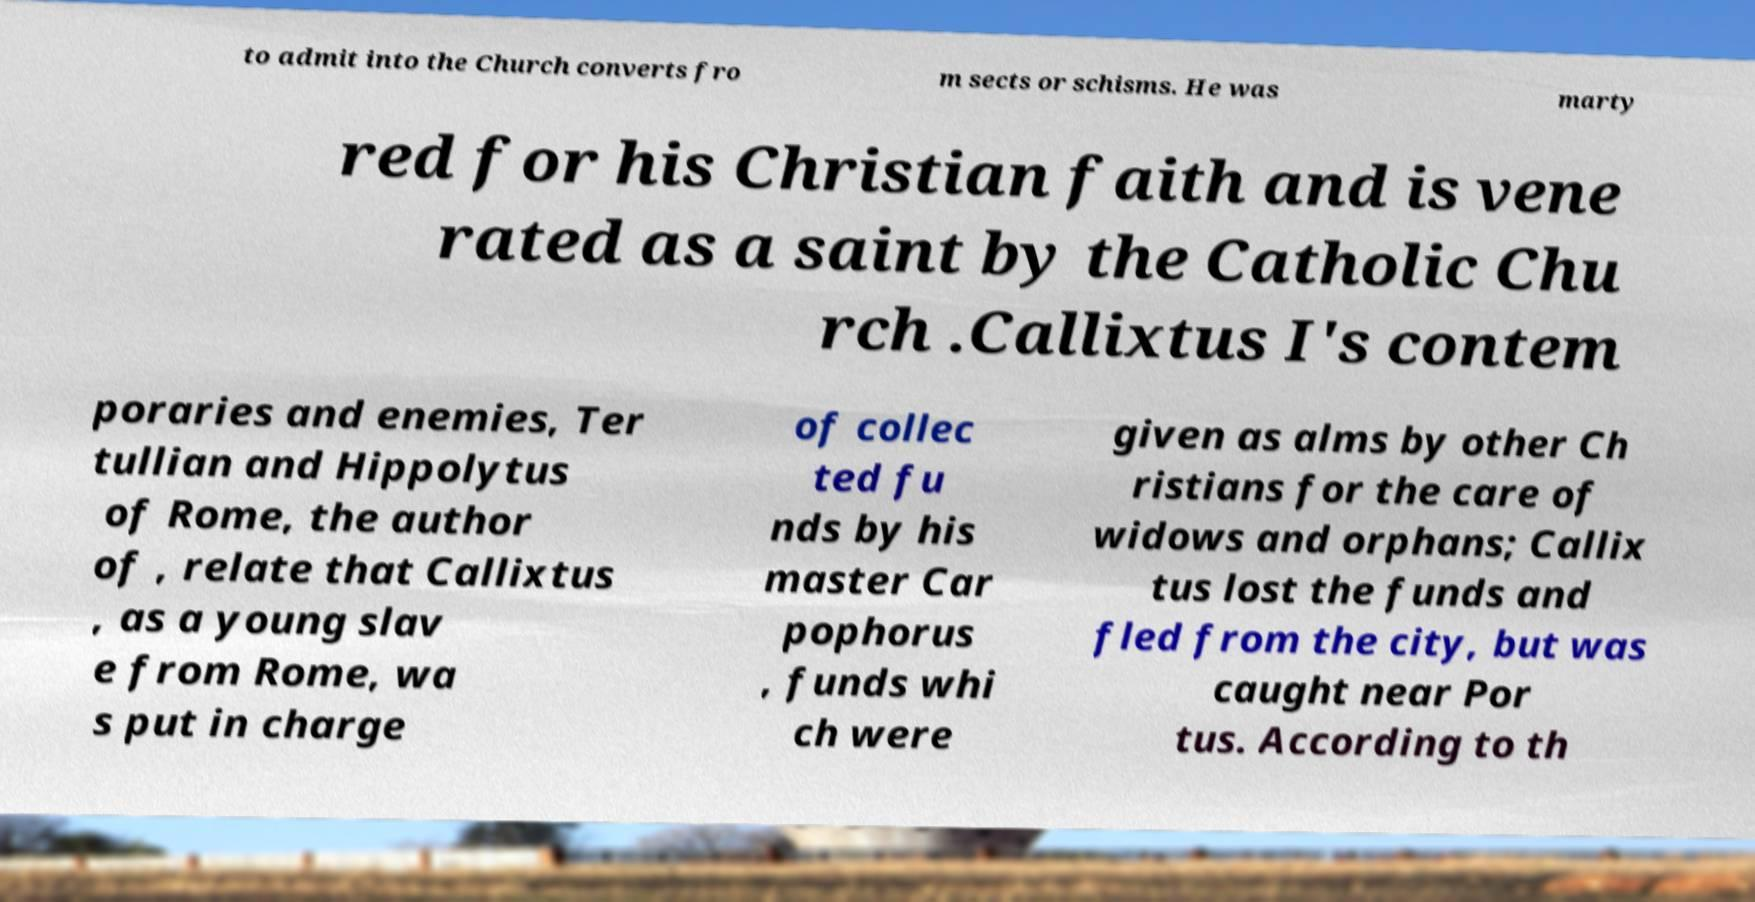Please read and relay the text visible in this image. What does it say? to admit into the Church converts fro m sects or schisms. He was marty red for his Christian faith and is vene rated as a saint by the Catholic Chu rch .Callixtus I's contem poraries and enemies, Ter tullian and Hippolytus of Rome, the author of , relate that Callixtus , as a young slav e from Rome, wa s put in charge of collec ted fu nds by his master Car pophorus , funds whi ch were given as alms by other Ch ristians for the care of widows and orphans; Callix tus lost the funds and fled from the city, but was caught near Por tus. According to th 